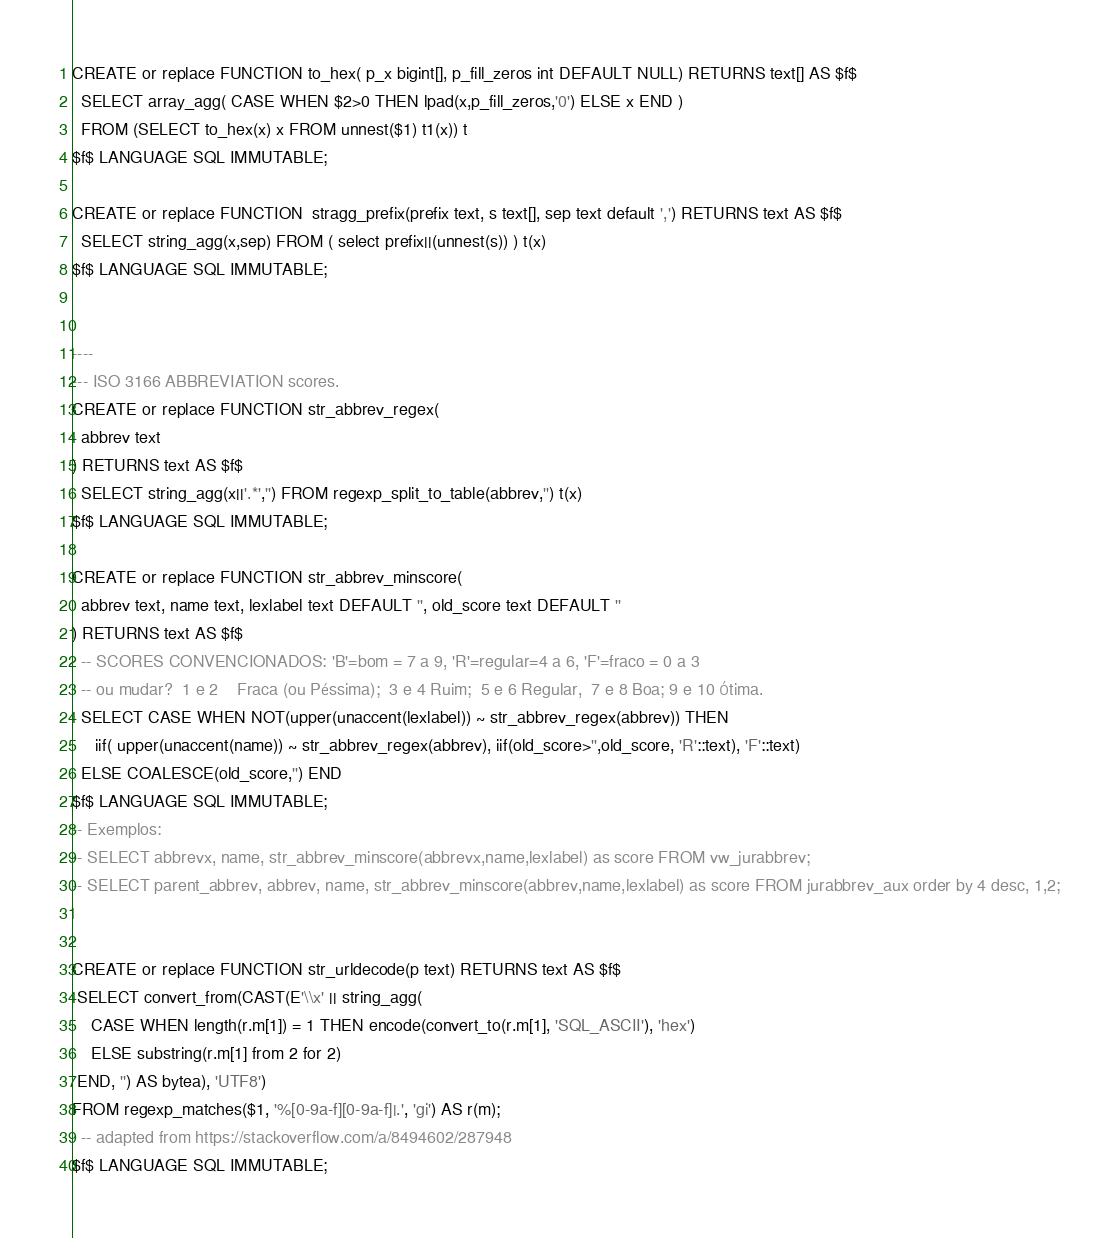<code> <loc_0><loc_0><loc_500><loc_500><_SQL_>CREATE or replace FUNCTION to_hex( p_x bigint[], p_fill_zeros int DEFAULT NULL) RETURNS text[] AS $f$
  SELECT array_agg( CASE WHEN $2>0 THEN lpad(x,p_fill_zeros,'0') ELSE x END )
  FROM (SELECT to_hex(x) x FROM unnest($1) t1(x)) t
$f$ LANGUAGE SQL IMMUTABLE;

CREATE or replace FUNCTION  stragg_prefix(prefix text, s text[], sep text default ',') RETURNS text AS $f$
  SELECT string_agg(x,sep) FROM ( select prefix||(unnest(s)) ) t(x)
$f$ LANGUAGE SQL IMMUTABLE;


----
--- ISO 3166 ABBREVIATION scores.
CREATE or replace FUNCTION str_abbrev_regex(
  abbrev text
) RETURNS text AS $f$
  SELECT string_agg(x||'.*','') FROM regexp_split_to_table(abbrev,'') t(x)
$f$ LANGUAGE SQL IMMUTABLE;

CREATE or replace FUNCTION str_abbrev_minscore(
  abbrev text, name text, lexlabel text DEFAULT '', old_score text DEFAULT ''
) RETURNS text AS $f$
  -- SCORES CONVENCIONADOS: 'B'=bom = 7 a 9, 'R'=regular=4 a 6, 'F'=fraco = 0 a 3
  -- ou mudar?  1 e 2    Fraca (ou Péssima);  3 e 4 Ruim;  5 e 6 Regular,  7 e 8 Boa; 9 e 10 Ótima.
  SELECT CASE WHEN NOT(upper(unaccent(lexlabel)) ~ str_abbrev_regex(abbrev)) THEN
     iif( upper(unaccent(name)) ~ str_abbrev_regex(abbrev), iif(old_score>'',old_score, 'R'::text), 'F'::text)
  ELSE COALESCE(old_score,'') END
$f$ LANGUAGE SQL IMMUTABLE;
-- Exemplos:
-- SELECT abbrevx, name, str_abbrev_minscore(abbrevx,name,lexlabel) as score FROM vw_jurabbrev;
-- SELECT parent_abbrev, abbrev, name, str_abbrev_minscore(abbrev,name,lexlabel) as score FROM jurabbrev_aux order by 4 desc, 1,2;


CREATE or replace FUNCTION str_urldecode(p text) RETURNS text AS $f$
 SELECT convert_from(CAST(E'\\x' || string_agg(
    CASE WHEN length(r.m[1]) = 1 THEN encode(convert_to(r.m[1], 'SQL_ASCII'), 'hex')
    ELSE substring(r.m[1] from 2 for 2)
 END, '') AS bytea), 'UTF8')
FROM regexp_matches($1, '%[0-9a-f][0-9a-f]|.', 'gi') AS r(m);
  -- adapted from https://stackoverflow.com/a/8494602/287948
$f$ LANGUAGE SQL IMMUTABLE;
</code> 